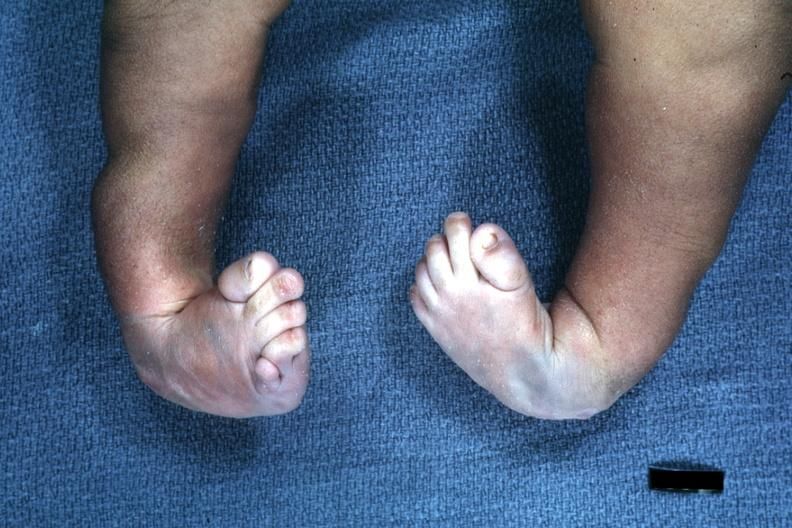how does this image show infant?
Answer the question using a single word or phrase. With club feet 